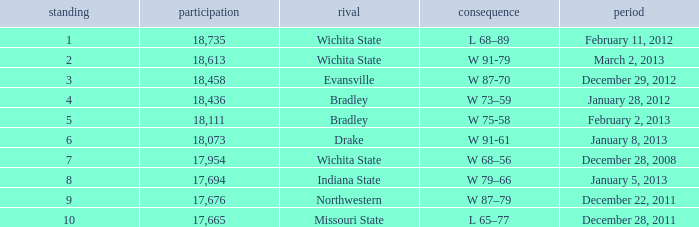What's the rank when attendance was less than 18,073 and having Northwestern as an opponent? 9.0. 